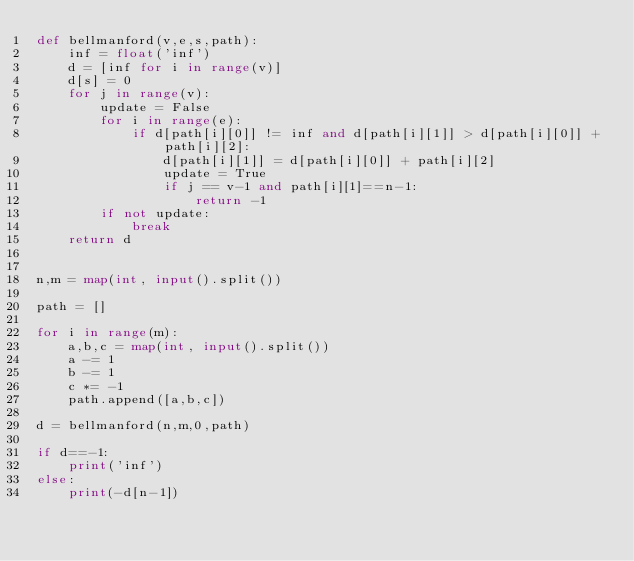<code> <loc_0><loc_0><loc_500><loc_500><_Python_>def bellmanford(v,e,s,path):
    inf = float('inf')
    d = [inf for i in range(v)]
    d[s] = 0
    for j in range(v):
        update = False
        for i in range(e):
            if d[path[i][0]] != inf and d[path[i][1]] > d[path[i][0]] + path[i][2]:
                d[path[i][1]] = d[path[i][0]] + path[i][2]
                update = True
                if j == v-1 and path[i][1]==n-1:
                    return -1
        if not update:
            break
    return d


n,m = map(int, input().split())

path = []

for i in range(m):
    a,b,c = map(int, input().split())
    a -= 1
    b -= 1
    c *= -1
    path.append([a,b,c])

d = bellmanford(n,m,0,path)

if d==-1:
    print('inf')
else:
    print(-d[n-1])</code> 